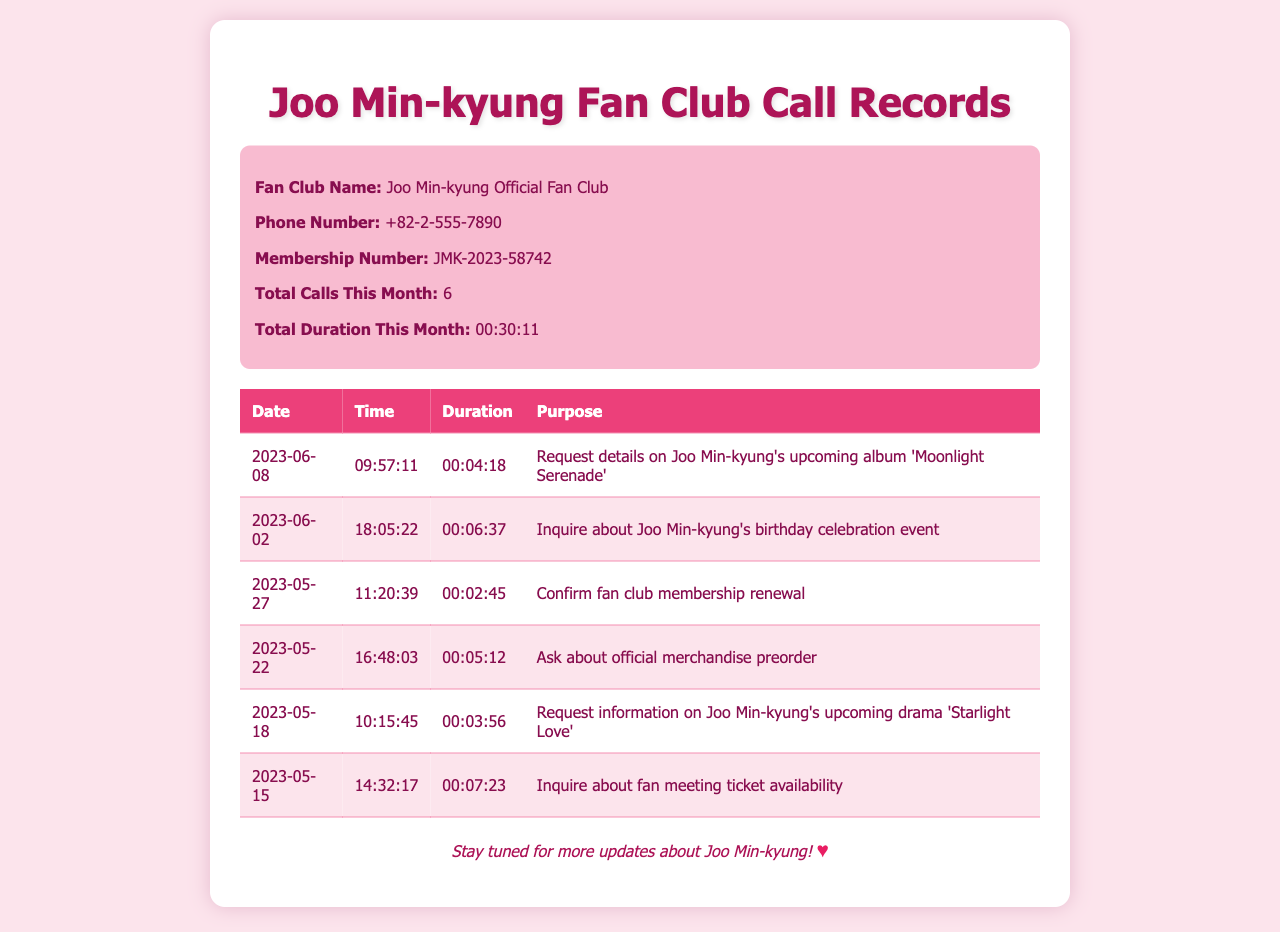What is the fan club name? The fan club name is mentioned in the document as Joo Min-kyung Official Fan Club.
Answer: Joo Min-kyung Official Fan Club What is the total call duration this month? The total duration for all calls made this month is specified as 00:30:11.
Answer: 00:30:11 How many calls have been made this month? The document states that there have been a total of 6 calls this month.
Answer: 6 What was the purpose of the call on 2023-06-08? The purpose of the call on that date was to request details on Joo Min-kyung's upcoming album 'Moonlight Serenade'.
Answer: Request details on Joo Min-kyung's upcoming album 'Moonlight Serenade' What was the duration of the call on 2023-06-02? The duration of the call on that date is mentioned as 00:06:37.
Answer: 00:06:37 Which merchandise was inquired about on 2023-05-22? The document indicates that the call was about asking about official merchandise preorder.
Answer: Official merchandise preorder Which call had the shortest duration? The shortest call duration mentioned is 00:02:45 on 2023-05-27.
Answer: 00:02:45 What is the hotline phone number? The hotline phone number for the fan club is provided as +82-2-555-7890.
Answer: +82-2-555-7890 When did the call regarding the fan meeting ticket availability occur? The call inquiring about fan meeting ticket availability took place on 2023-05-15.
Answer: 2023-05-15 